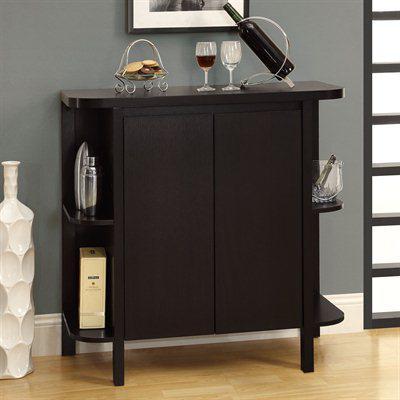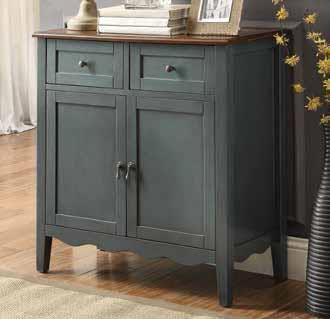The first image is the image on the left, the second image is the image on the right. Analyze the images presented: Is the assertion "At least one of the cabinets is dark and has no glass-front doors, and none of the cabinets are distinctly taller than they are wide." valid? Answer yes or no. Yes. The first image is the image on the left, the second image is the image on the right. Analyze the images presented: Is the assertion "A tall, wide wooden hutch has an upper section with at least three doors that sits directly on a lower section with two panel doors and at least three drawers." valid? Answer yes or no. No. 